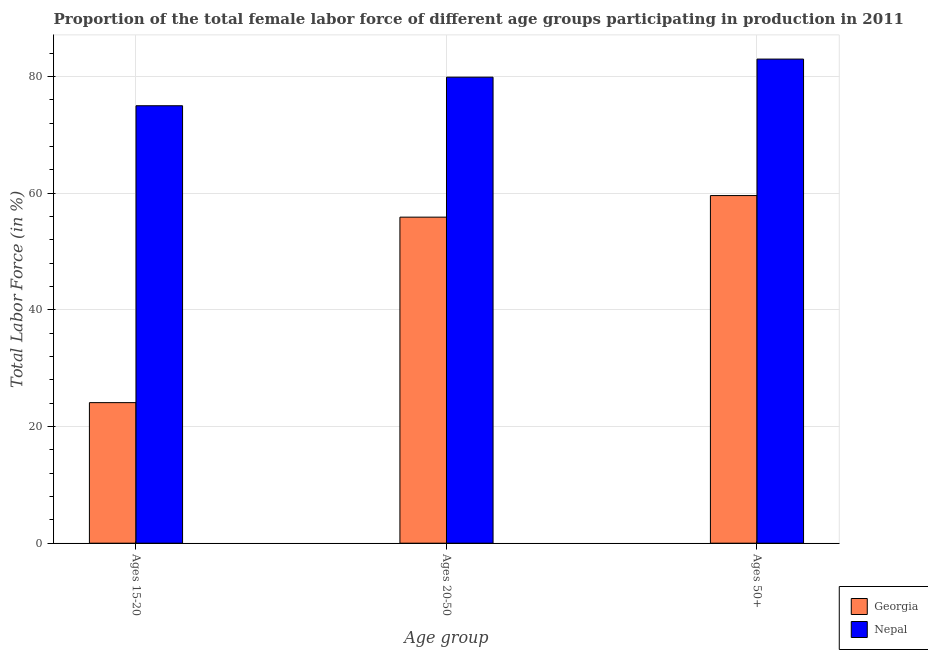How many different coloured bars are there?
Ensure brevity in your answer.  2. Are the number of bars on each tick of the X-axis equal?
Give a very brief answer. Yes. How many bars are there on the 2nd tick from the right?
Provide a succinct answer. 2. What is the label of the 3rd group of bars from the left?
Make the answer very short. Ages 50+. What is the percentage of female labor force within the age group 20-50 in Nepal?
Provide a succinct answer. 79.9. Across all countries, what is the minimum percentage of female labor force above age 50?
Your answer should be compact. 59.6. In which country was the percentage of female labor force above age 50 maximum?
Offer a very short reply. Nepal. In which country was the percentage of female labor force within the age group 15-20 minimum?
Keep it short and to the point. Georgia. What is the total percentage of female labor force above age 50 in the graph?
Ensure brevity in your answer.  142.6. What is the difference between the percentage of female labor force within the age group 20-50 in Nepal and that in Georgia?
Your answer should be compact. 24. What is the difference between the percentage of female labor force above age 50 in Nepal and the percentage of female labor force within the age group 15-20 in Georgia?
Your response must be concise. 58.9. What is the average percentage of female labor force above age 50 per country?
Your answer should be very brief. 71.3. What is the difference between the percentage of female labor force within the age group 15-20 and percentage of female labor force above age 50 in Nepal?
Give a very brief answer. -8. What is the ratio of the percentage of female labor force within the age group 15-20 in Georgia to that in Nepal?
Ensure brevity in your answer.  0.32. Is the percentage of female labor force within the age group 15-20 in Nepal less than that in Georgia?
Your response must be concise. No. What is the difference between the highest and the second highest percentage of female labor force within the age group 15-20?
Your answer should be very brief. 50.9. What is the difference between the highest and the lowest percentage of female labor force within the age group 15-20?
Give a very brief answer. 50.9. In how many countries, is the percentage of female labor force within the age group 20-50 greater than the average percentage of female labor force within the age group 20-50 taken over all countries?
Your answer should be very brief. 1. What does the 2nd bar from the left in Ages 15-20 represents?
Provide a succinct answer. Nepal. What does the 2nd bar from the right in Ages 15-20 represents?
Ensure brevity in your answer.  Georgia. Is it the case that in every country, the sum of the percentage of female labor force within the age group 15-20 and percentage of female labor force within the age group 20-50 is greater than the percentage of female labor force above age 50?
Your answer should be very brief. Yes. Are the values on the major ticks of Y-axis written in scientific E-notation?
Your answer should be compact. No. Does the graph contain any zero values?
Keep it short and to the point. No. Does the graph contain grids?
Give a very brief answer. Yes. Where does the legend appear in the graph?
Your response must be concise. Bottom right. How are the legend labels stacked?
Provide a short and direct response. Vertical. What is the title of the graph?
Your answer should be compact. Proportion of the total female labor force of different age groups participating in production in 2011. Does "Belize" appear as one of the legend labels in the graph?
Make the answer very short. No. What is the label or title of the X-axis?
Make the answer very short. Age group. What is the label or title of the Y-axis?
Your response must be concise. Total Labor Force (in %). What is the Total Labor Force (in %) in Georgia in Ages 15-20?
Provide a succinct answer. 24.1. What is the Total Labor Force (in %) in Georgia in Ages 20-50?
Provide a succinct answer. 55.9. What is the Total Labor Force (in %) of Nepal in Ages 20-50?
Make the answer very short. 79.9. What is the Total Labor Force (in %) of Georgia in Ages 50+?
Provide a short and direct response. 59.6. Across all Age group, what is the maximum Total Labor Force (in %) in Georgia?
Provide a succinct answer. 59.6. Across all Age group, what is the maximum Total Labor Force (in %) in Nepal?
Offer a very short reply. 83. Across all Age group, what is the minimum Total Labor Force (in %) of Georgia?
Keep it short and to the point. 24.1. Across all Age group, what is the minimum Total Labor Force (in %) of Nepal?
Provide a short and direct response. 75. What is the total Total Labor Force (in %) in Georgia in the graph?
Your answer should be very brief. 139.6. What is the total Total Labor Force (in %) in Nepal in the graph?
Offer a very short reply. 237.9. What is the difference between the Total Labor Force (in %) in Georgia in Ages 15-20 and that in Ages 20-50?
Your answer should be very brief. -31.8. What is the difference between the Total Labor Force (in %) of Georgia in Ages 15-20 and that in Ages 50+?
Offer a very short reply. -35.5. What is the difference between the Total Labor Force (in %) of Nepal in Ages 15-20 and that in Ages 50+?
Your response must be concise. -8. What is the difference between the Total Labor Force (in %) of Georgia in Ages 20-50 and that in Ages 50+?
Offer a terse response. -3.7. What is the difference between the Total Labor Force (in %) of Georgia in Ages 15-20 and the Total Labor Force (in %) of Nepal in Ages 20-50?
Ensure brevity in your answer.  -55.8. What is the difference between the Total Labor Force (in %) in Georgia in Ages 15-20 and the Total Labor Force (in %) in Nepal in Ages 50+?
Provide a short and direct response. -58.9. What is the difference between the Total Labor Force (in %) of Georgia in Ages 20-50 and the Total Labor Force (in %) of Nepal in Ages 50+?
Provide a short and direct response. -27.1. What is the average Total Labor Force (in %) in Georgia per Age group?
Make the answer very short. 46.53. What is the average Total Labor Force (in %) of Nepal per Age group?
Give a very brief answer. 79.3. What is the difference between the Total Labor Force (in %) in Georgia and Total Labor Force (in %) in Nepal in Ages 15-20?
Offer a very short reply. -50.9. What is the difference between the Total Labor Force (in %) of Georgia and Total Labor Force (in %) of Nepal in Ages 50+?
Your response must be concise. -23.4. What is the ratio of the Total Labor Force (in %) of Georgia in Ages 15-20 to that in Ages 20-50?
Your answer should be compact. 0.43. What is the ratio of the Total Labor Force (in %) in Nepal in Ages 15-20 to that in Ages 20-50?
Keep it short and to the point. 0.94. What is the ratio of the Total Labor Force (in %) of Georgia in Ages 15-20 to that in Ages 50+?
Your response must be concise. 0.4. What is the ratio of the Total Labor Force (in %) in Nepal in Ages 15-20 to that in Ages 50+?
Ensure brevity in your answer.  0.9. What is the ratio of the Total Labor Force (in %) in Georgia in Ages 20-50 to that in Ages 50+?
Your response must be concise. 0.94. What is the ratio of the Total Labor Force (in %) of Nepal in Ages 20-50 to that in Ages 50+?
Give a very brief answer. 0.96. What is the difference between the highest and the second highest Total Labor Force (in %) of Georgia?
Keep it short and to the point. 3.7. What is the difference between the highest and the second highest Total Labor Force (in %) of Nepal?
Provide a succinct answer. 3.1. What is the difference between the highest and the lowest Total Labor Force (in %) in Georgia?
Your answer should be very brief. 35.5. 